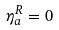Convert formula to latex. <formula><loc_0><loc_0><loc_500><loc_500>\eta ^ { R } _ { a } = 0</formula> 